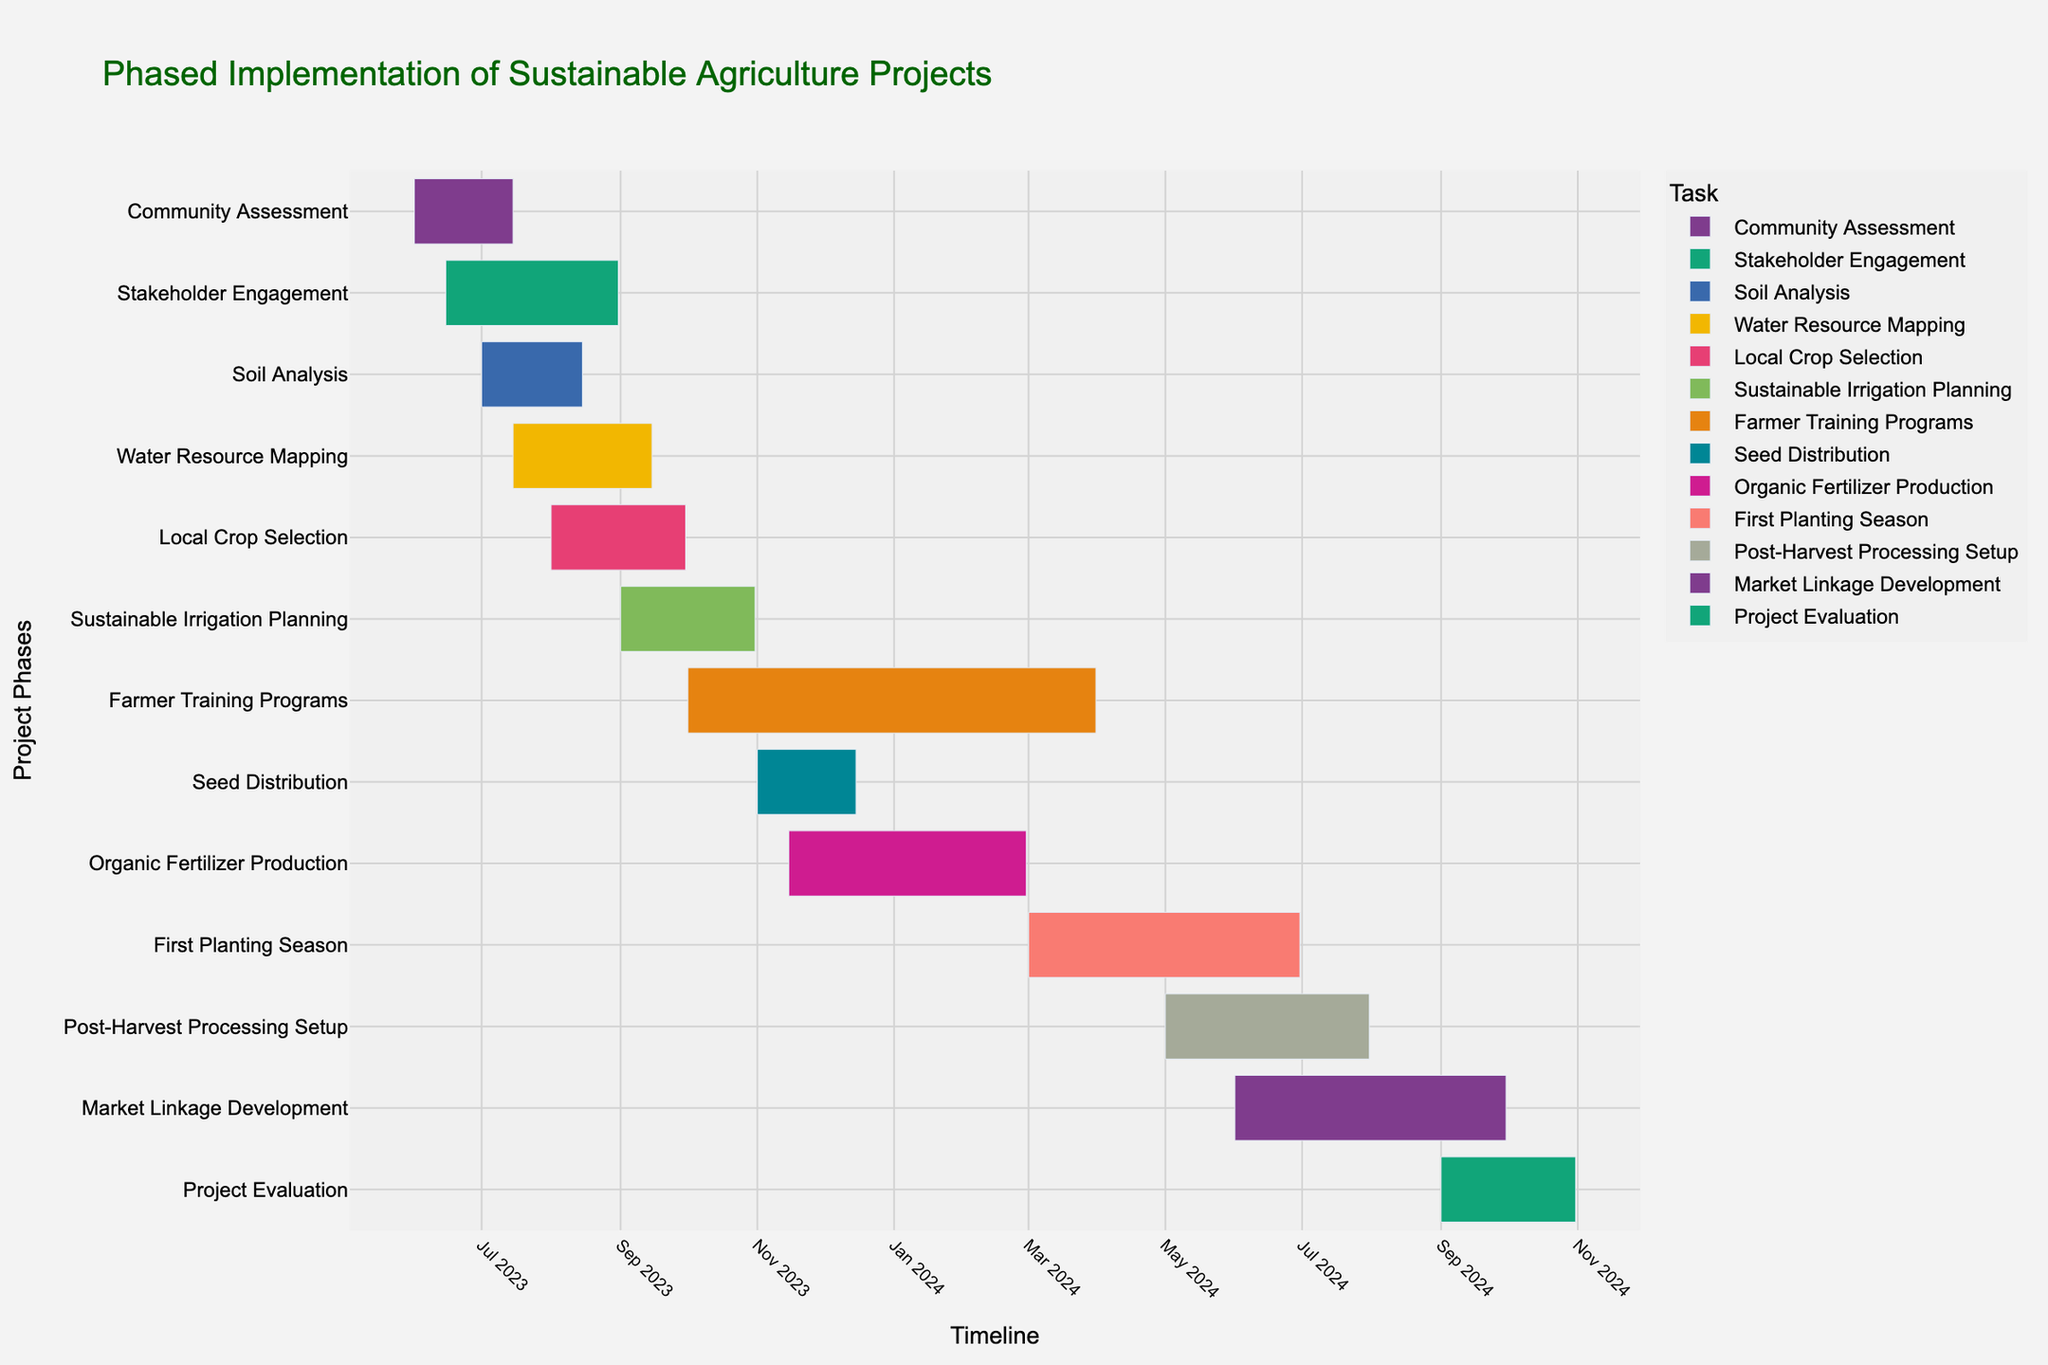What's the title of the Gantt chart? The title is usually displayed at the top of the chart and provides an overview of what the chart represents. In this case, it tells us the subject and purpose of the Gantt chart.
Answer: Phased Implementation of Sustainable Agriculture Projects What are the start and end dates for the "Community Assessment" task? Look for the "Community Assessment" task on the y-axis, then follow it horizontally to find its start and end dates listed on the x-axis.
Answer: June 1, 2023 to July 15, 2023 How long does the "Farmer Training Programs" task last? Identify the "Farmer Training Programs" task on the y-axis and note its start and end dates on the x-axis. The duration is the difference between these two dates.
Answer: 6 months Which task starts simultaneously with "Soil Analysis"? Find the start date of the "Soil Analysis" task, and then locate other tasks that begin on the same date.
Answer: Stakeholder Engagement Which tasks are overlapping with "Water Resource Mapping"? Identify the start and end dates for "Water Resource Mapping" and find other tasks that have any intersection with this time period.
Answer: Stakeholder Engagement, Soil Analysis, Local Crop Selection Which task has the shortest duration? Compare the durations of all tasks visually. The shortest bar lengths indicate shorter durations.
Answer: Seed Distribution What's the chronological order of tasks that start after "Local Crop Selection"? First, find the end date of "Local Crop Selection," then list subsequent tasks according to their start dates.
Answer: Sustainable Irrigation Planning, Farmer Training Programs, Seed Distribution, Organic Fertilizer Production, First Planting Season, Post-Harvest Processing Setup, Market Linkage Development, Project Evaluation How many tasks are planned to start in November 2023? Locate the month of November 2023 on the x-axis and count the number of tasks that have their start dates in this month.
Answer: 2 What is the overlapping duration between "First Planting Season" and "Post-Harvest Processing Setup"? Identify the overlapping period by noting the start of the overlapping section and the end of the earliest overlapping task. Calculate its duration.
Answer: 2 months Which task ends last? Identify the task that has the latest end date by looking at the right-most end of its bar on the timeline.
Answer: Project Evaluation 